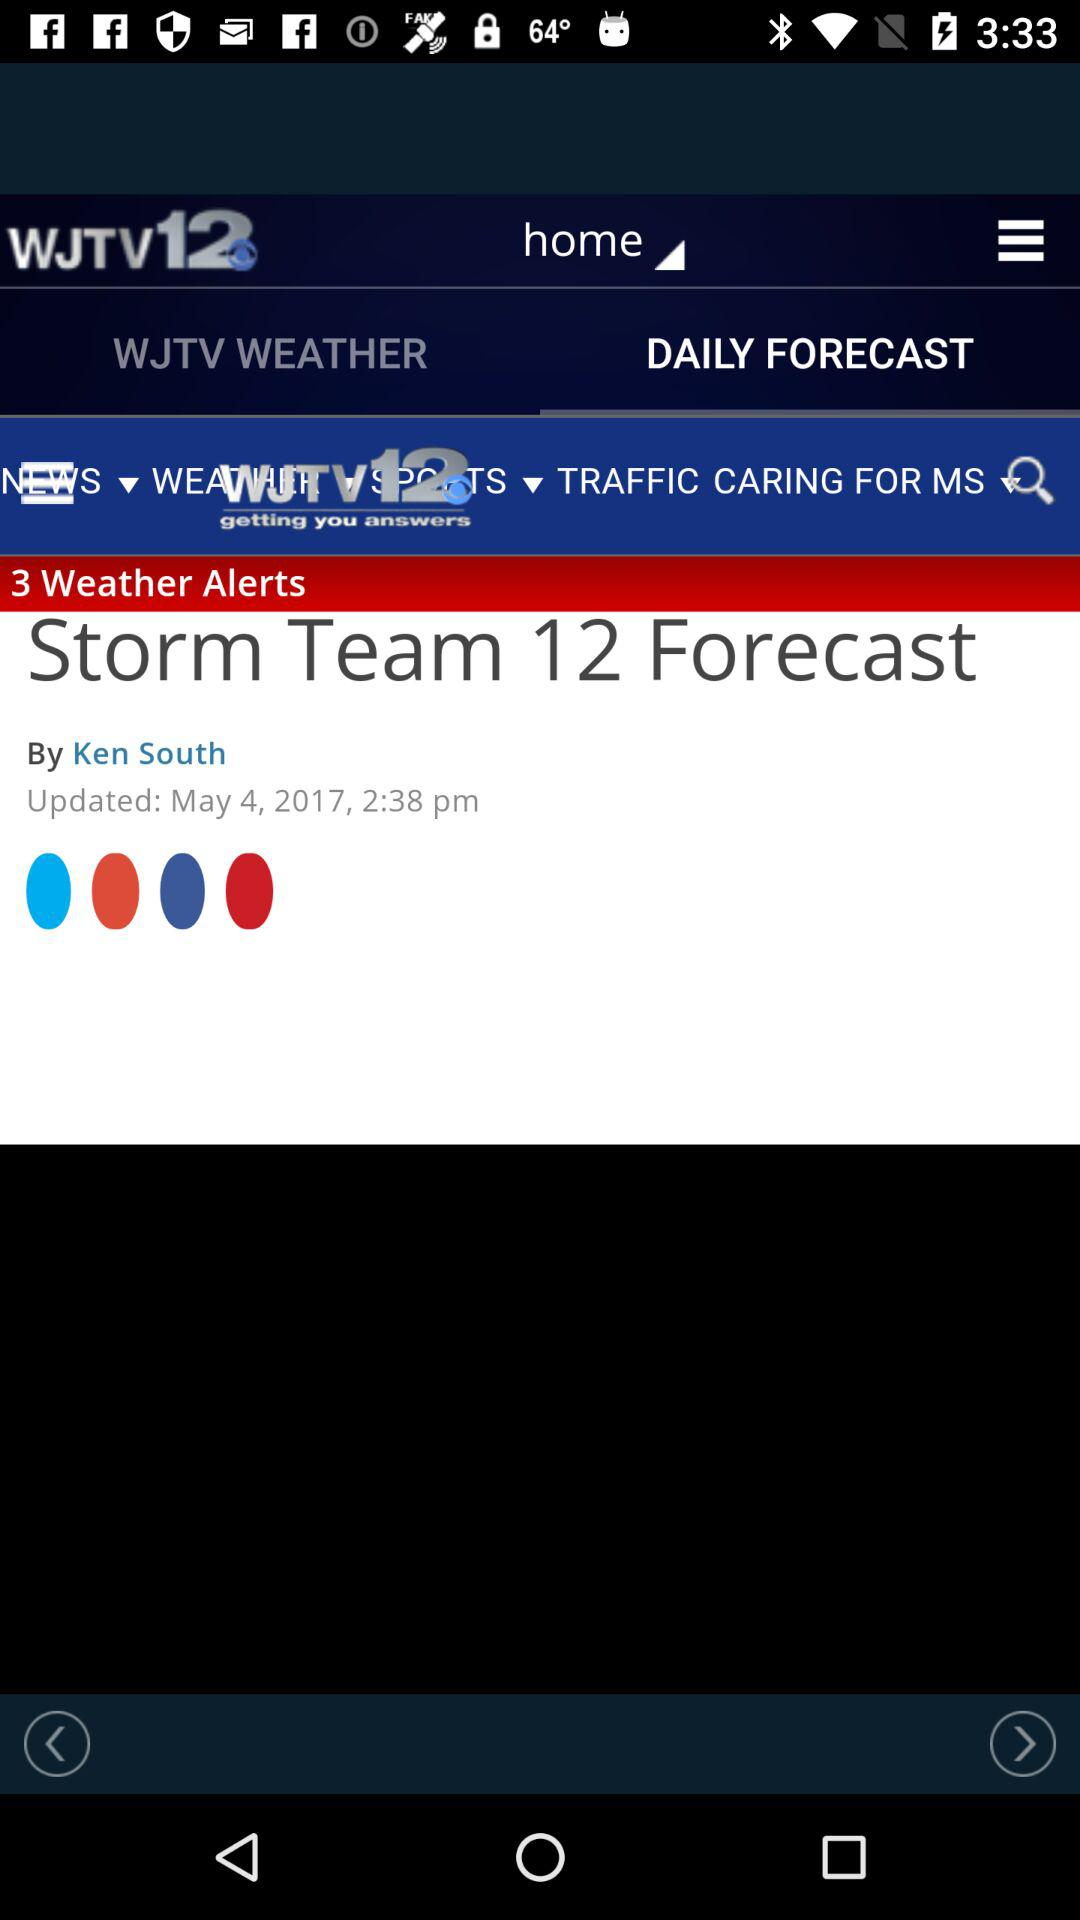What is the name of the application? The application name is "WJTV12". 